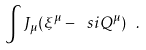<formula> <loc_0><loc_0><loc_500><loc_500>\int J _ { \mu } ( \xi ^ { \mu } - \ s i Q ^ { \mu } ) \ .</formula> 